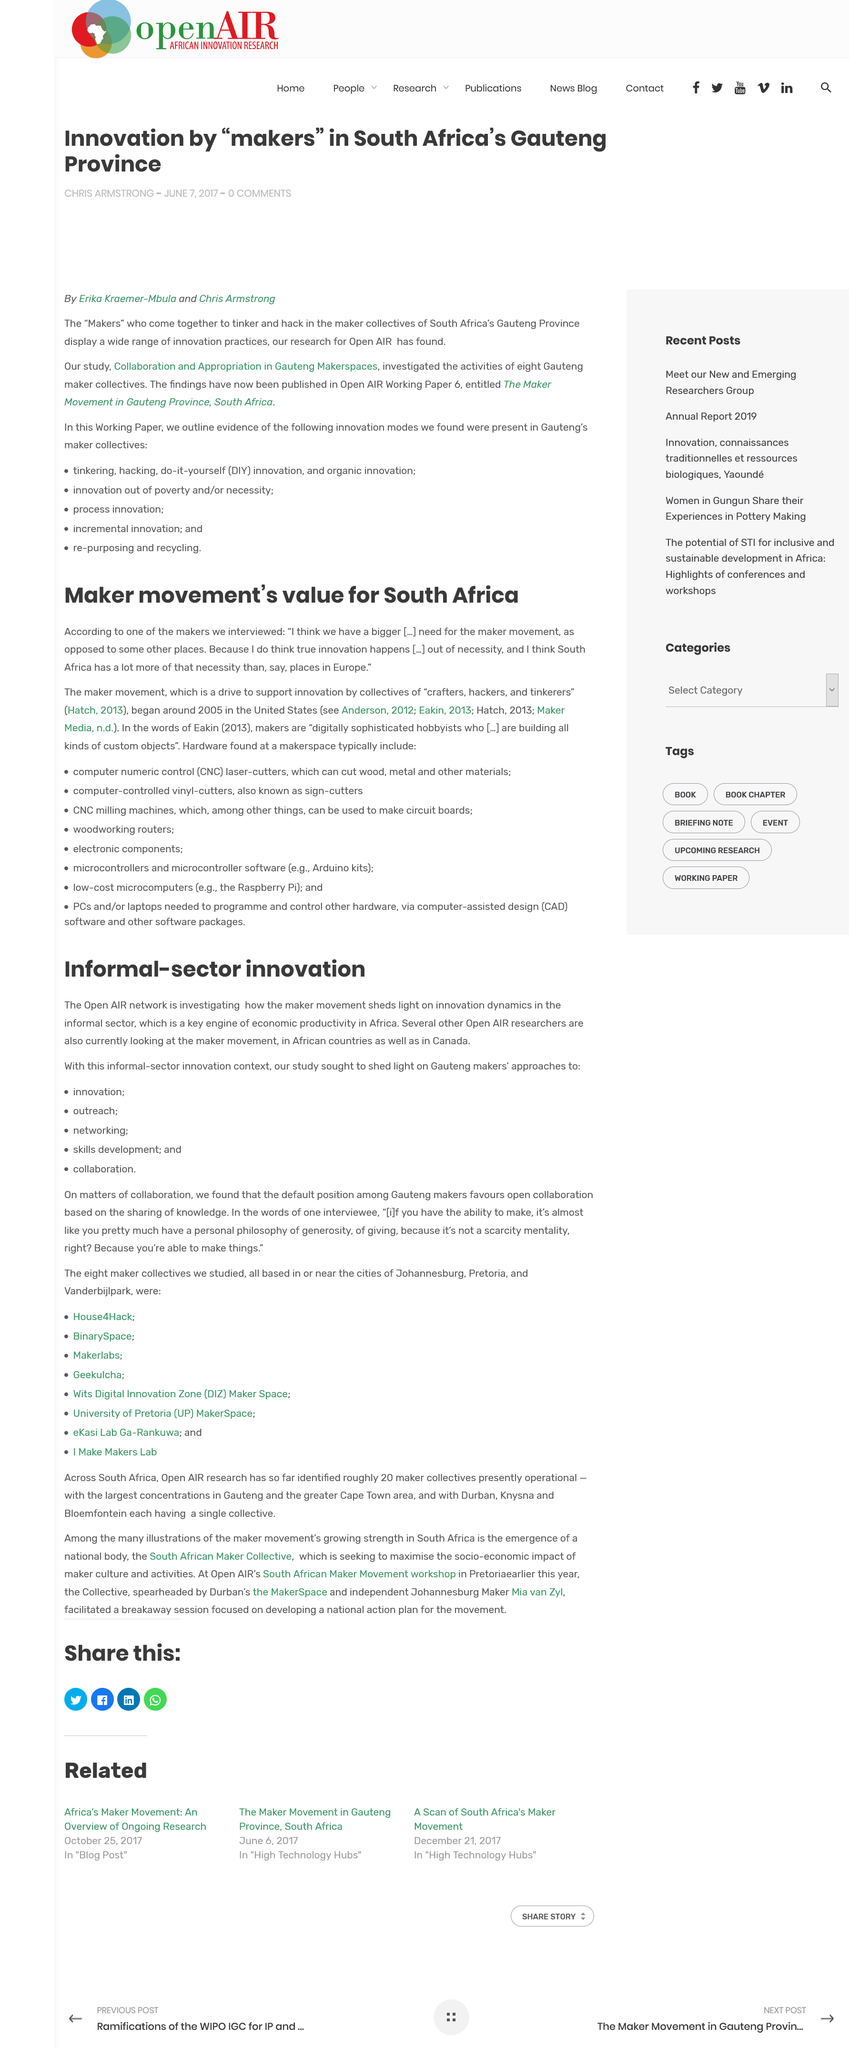Draw attention to some important aspects in this diagram. The makers interviewed stated that true innovations occur as a result of necessity. The Maker Movement is a driving force for innovation and supports the development of new ideas and technologies. 